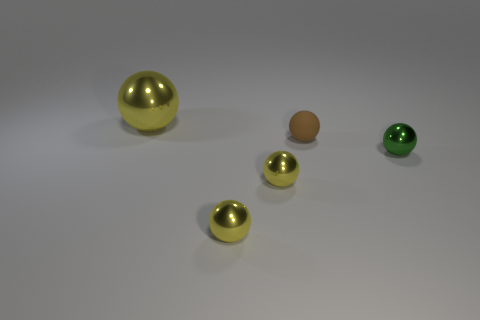What size is the rubber object that is the same shape as the large metallic object?
Make the answer very short. Small. What number of other objects are the same material as the big yellow thing?
Offer a terse response. 3. There is a metal sphere behind the brown object; what number of tiny balls are to the right of it?
Give a very brief answer. 4. Are there any other things that are the same shape as the small green metallic thing?
Your response must be concise. Yes. There is a object behind the tiny brown matte thing; is its color the same as the object that is to the right of the brown sphere?
Your answer should be compact. No. Is the number of red things less than the number of tiny matte objects?
Give a very brief answer. Yes. What shape is the thing right of the small ball behind the small green ball?
Ensure brevity in your answer.  Sphere. Is there anything else that is the same size as the green ball?
Offer a terse response. Yes. How many objects are yellow shiny objects that are in front of the brown sphere or large metal spheres to the left of the green object?
Your response must be concise. 3. There is a brown thing; is its size the same as the metallic ball behind the small green ball?
Make the answer very short. No. 